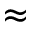<formula> <loc_0><loc_0><loc_500><loc_500>\approx</formula> 